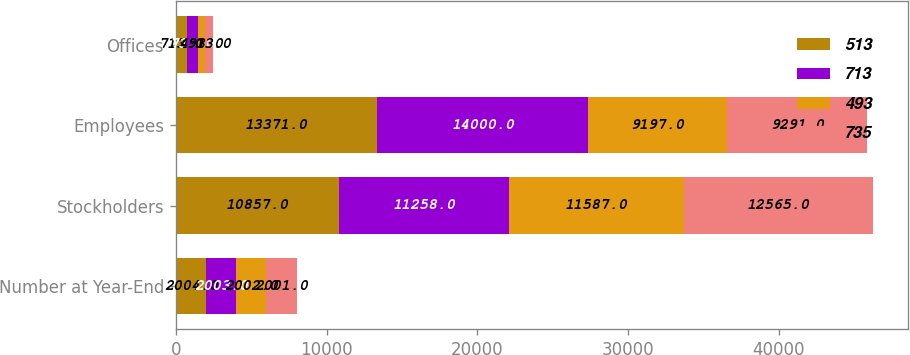Convert chart. <chart><loc_0><loc_0><loc_500><loc_500><stacked_bar_chart><ecel><fcel>Number at Year-End<fcel>Stockholders<fcel>Employees<fcel>Offices<nl><fcel>513<fcel>2004<fcel>10857<fcel>13371<fcel>713<nl><fcel>713<fcel>2003<fcel>11258<fcel>14000<fcel>735<nl><fcel>493<fcel>2002<fcel>11587<fcel>9197<fcel>493<nl><fcel>735<fcel>2001<fcel>12565<fcel>9291<fcel>513<nl></chart> 